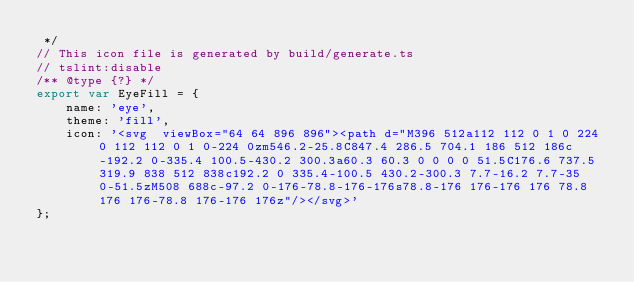Convert code to text. <code><loc_0><loc_0><loc_500><loc_500><_JavaScript_> */
// This icon file is generated by build/generate.ts
// tslint:disable
/** @type {?} */
export var EyeFill = {
    name: 'eye',
    theme: 'fill',
    icon: '<svg  viewBox="64 64 896 896"><path d="M396 512a112 112 0 1 0 224 0 112 112 0 1 0-224 0zm546.2-25.8C847.4 286.5 704.1 186 512 186c-192.2 0-335.4 100.5-430.2 300.3a60.3 60.3 0 0 0 0 51.5C176.6 737.5 319.9 838 512 838c192.2 0 335.4-100.5 430.2-300.3 7.7-16.2 7.7-35 0-51.5zM508 688c-97.2 0-176-78.8-176-176s78.8-176 176-176 176 78.8 176 176-78.8 176-176 176z"/></svg>'
};</code> 